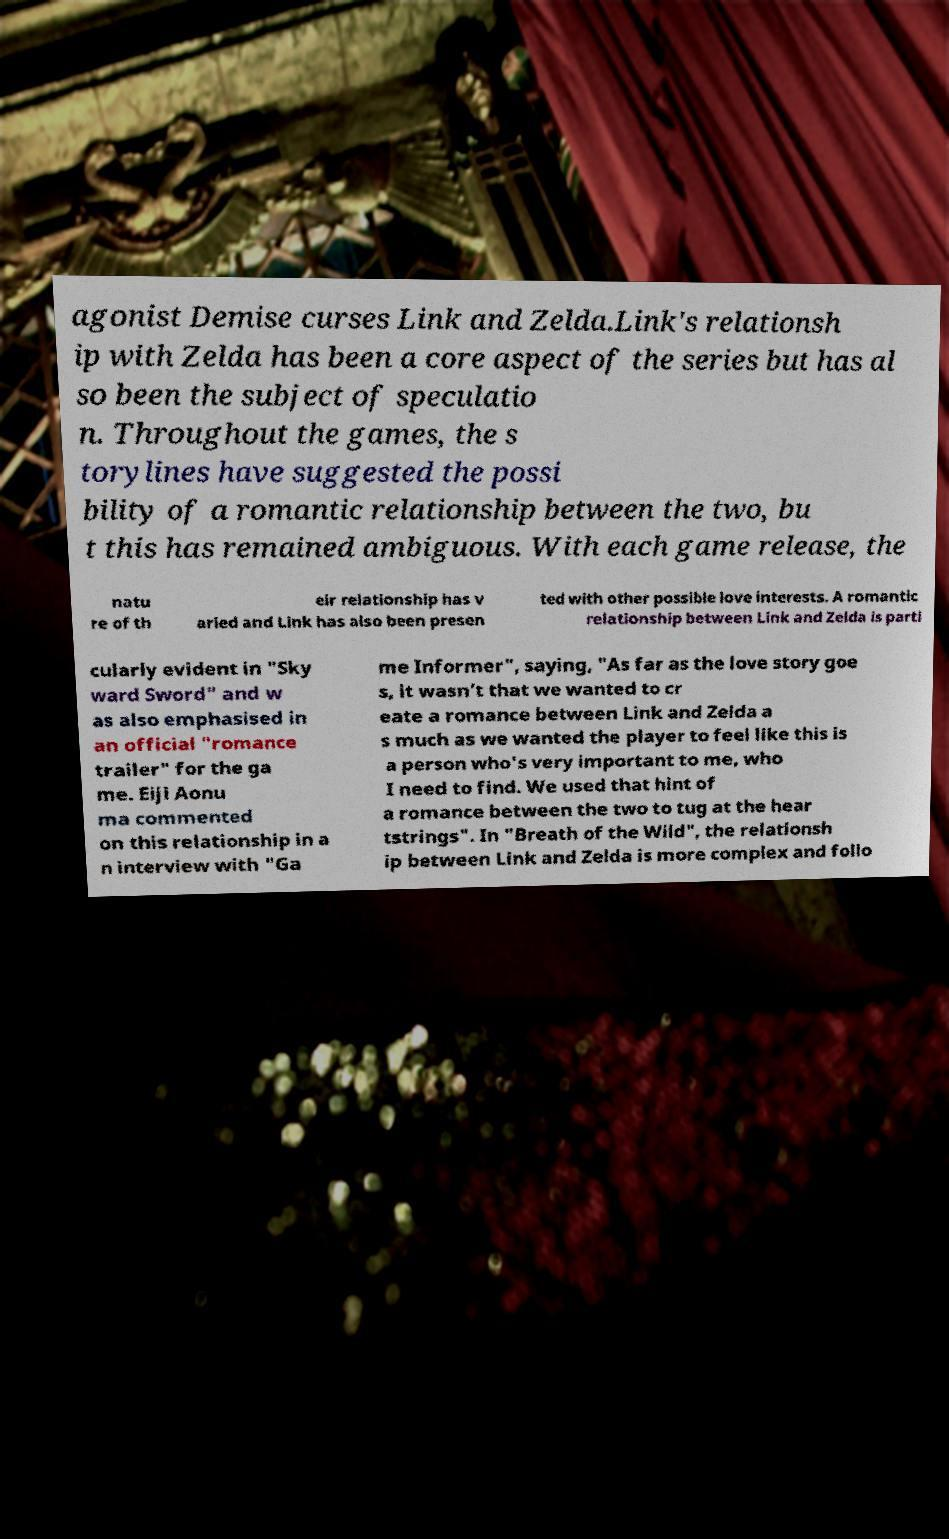For documentation purposes, I need the text within this image transcribed. Could you provide that? agonist Demise curses Link and Zelda.Link's relationsh ip with Zelda has been a core aspect of the series but has al so been the subject of speculatio n. Throughout the games, the s torylines have suggested the possi bility of a romantic relationship between the two, bu t this has remained ambiguous. With each game release, the natu re of th eir relationship has v aried and Link has also been presen ted with other possible love interests. A romantic relationship between Link and Zelda is parti cularly evident in "Sky ward Sword" and w as also emphasised in an official "romance trailer" for the ga me. Eiji Aonu ma commented on this relationship in a n interview with "Ga me Informer", saying, "As far as the love story goe s, it wasn’t that we wanted to cr eate a romance between Link and Zelda a s much as we wanted the player to feel like this is a person who's very important to me, who I need to find. We used that hint of a romance between the two to tug at the hear tstrings". In "Breath of the Wild", the relationsh ip between Link and Zelda is more complex and follo 